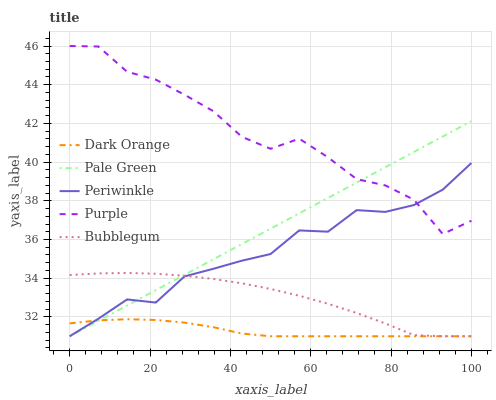Does Dark Orange have the minimum area under the curve?
Answer yes or no. Yes. Does Purple have the maximum area under the curve?
Answer yes or no. Yes. Does Pale Green have the minimum area under the curve?
Answer yes or no. No. Does Pale Green have the maximum area under the curve?
Answer yes or no. No. Is Pale Green the smoothest?
Answer yes or no. Yes. Is Purple the roughest?
Answer yes or no. Yes. Is Dark Orange the smoothest?
Answer yes or no. No. Is Dark Orange the roughest?
Answer yes or no. No. Does Pale Green have the highest value?
Answer yes or no. No. Is Dark Orange less than Purple?
Answer yes or no. Yes. Is Purple greater than Dark Orange?
Answer yes or no. Yes. Does Dark Orange intersect Purple?
Answer yes or no. No. 